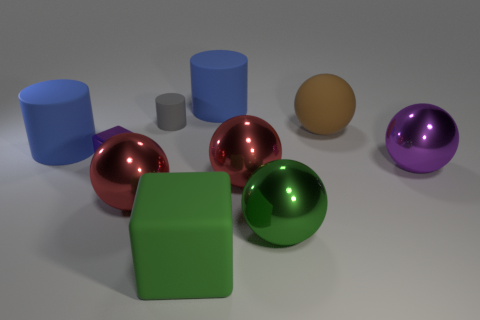Which objects in the image look similar and why? The red and purple balls appear similar because they both have a shiny, metallic surface, reflecting light and the environment, which results in a lustrous appearance. Their similar spherical shape and reflective qualities draw a visual parallel between them. Are there any elements that provide a sense of scale in this scene? Without familiar objects or a known environment, it's difficult to determine the exact scale. However, the relative sizes of the objects to each other provide a sense of scale within the scene itself. For example, the small grey cylinder appears diminutive in comparison to the larger blue cylinder, offering some sense of scale. 